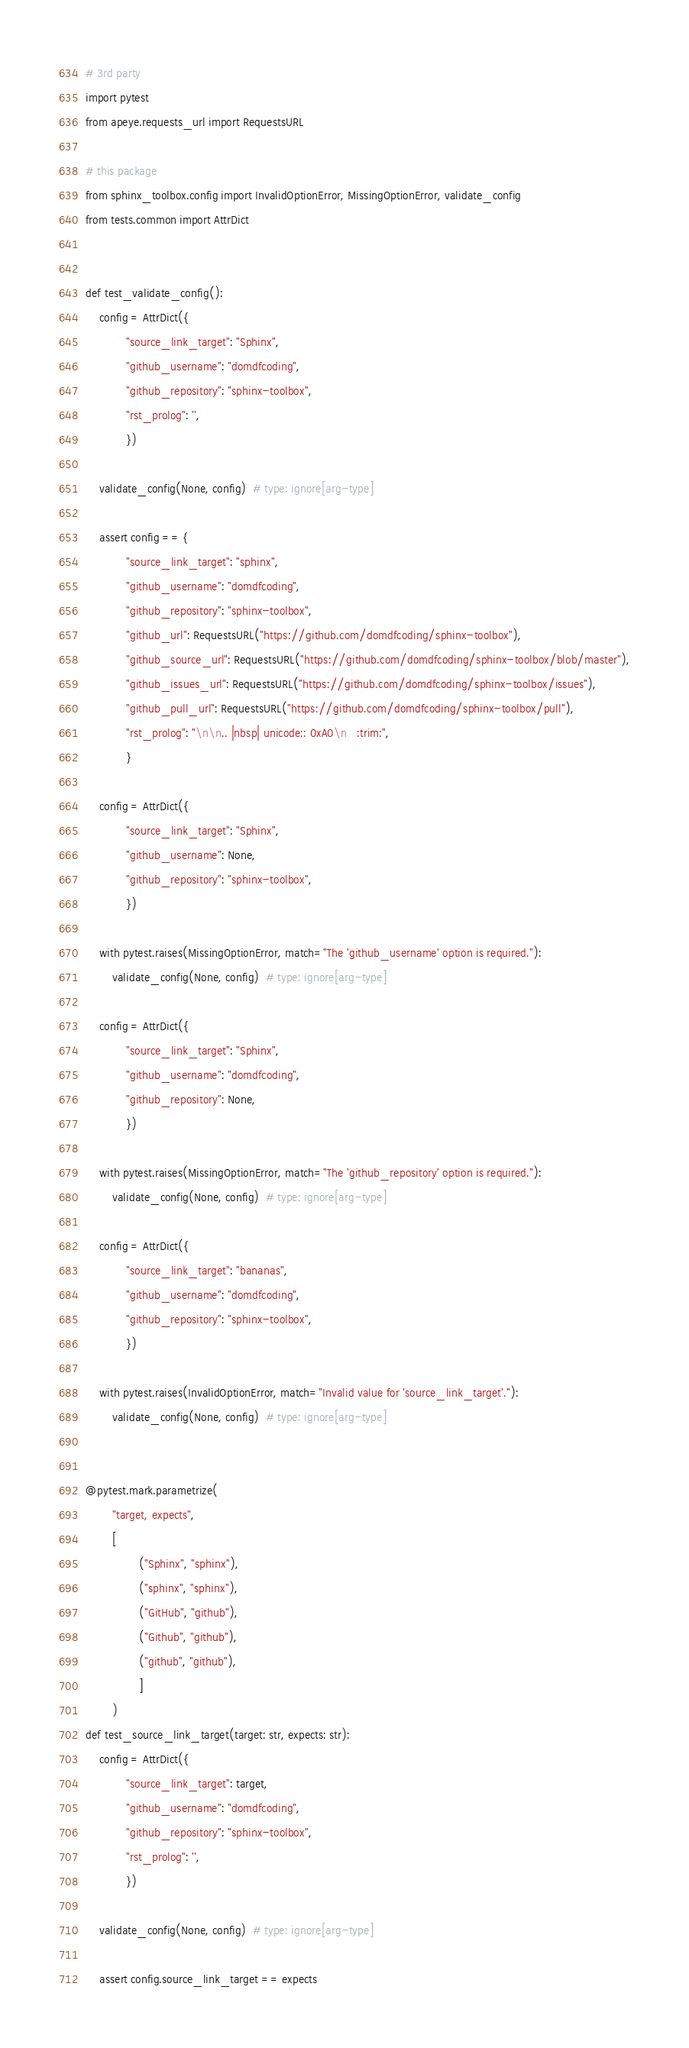<code> <loc_0><loc_0><loc_500><loc_500><_Python_># 3rd party
import pytest
from apeye.requests_url import RequestsURL

# this package
from sphinx_toolbox.config import InvalidOptionError, MissingOptionError, validate_config
from tests.common import AttrDict


def test_validate_config():
	config = AttrDict({
			"source_link_target": "Sphinx",
			"github_username": "domdfcoding",
			"github_repository": "sphinx-toolbox",
			"rst_prolog": '',
			})

	validate_config(None, config)  # type: ignore[arg-type]

	assert config == {
			"source_link_target": "sphinx",
			"github_username": "domdfcoding",
			"github_repository": "sphinx-toolbox",
			"github_url": RequestsURL("https://github.com/domdfcoding/sphinx-toolbox"),
			"github_source_url": RequestsURL("https://github.com/domdfcoding/sphinx-toolbox/blob/master"),
			"github_issues_url": RequestsURL("https://github.com/domdfcoding/sphinx-toolbox/issues"),
			"github_pull_url": RequestsURL("https://github.com/domdfcoding/sphinx-toolbox/pull"),
			"rst_prolog": "\n\n.. |nbsp| unicode:: 0xA0\n   :trim:",
			}

	config = AttrDict({
			"source_link_target": "Sphinx",
			"github_username": None,
			"github_repository": "sphinx-toolbox",
			})

	with pytest.raises(MissingOptionError, match="The 'github_username' option is required."):
		validate_config(None, config)  # type: ignore[arg-type]

	config = AttrDict({
			"source_link_target": "Sphinx",
			"github_username": "domdfcoding",
			"github_repository": None,
			})

	with pytest.raises(MissingOptionError, match="The 'github_repository' option is required."):
		validate_config(None, config)  # type: ignore[arg-type]

	config = AttrDict({
			"source_link_target": "bananas",
			"github_username": "domdfcoding",
			"github_repository": "sphinx-toolbox",
			})

	with pytest.raises(InvalidOptionError, match="Invalid value for 'source_link_target'."):
		validate_config(None, config)  # type: ignore[arg-type]


@pytest.mark.parametrize(
		"target, expects",
		[
				("Sphinx", "sphinx"),
				("sphinx", "sphinx"),
				("GitHub", "github"),
				("Github", "github"),
				("github", "github"),
				]
		)
def test_source_link_target(target: str, expects: str):
	config = AttrDict({
			"source_link_target": target,
			"github_username": "domdfcoding",
			"github_repository": "sphinx-toolbox",
			"rst_prolog": '',
			})

	validate_config(None, config)  # type: ignore[arg-type]

	assert config.source_link_target == expects
</code> 